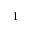Convert formula to latex. <formula><loc_0><loc_0><loc_500><loc_500>^ { 1 }</formula> 